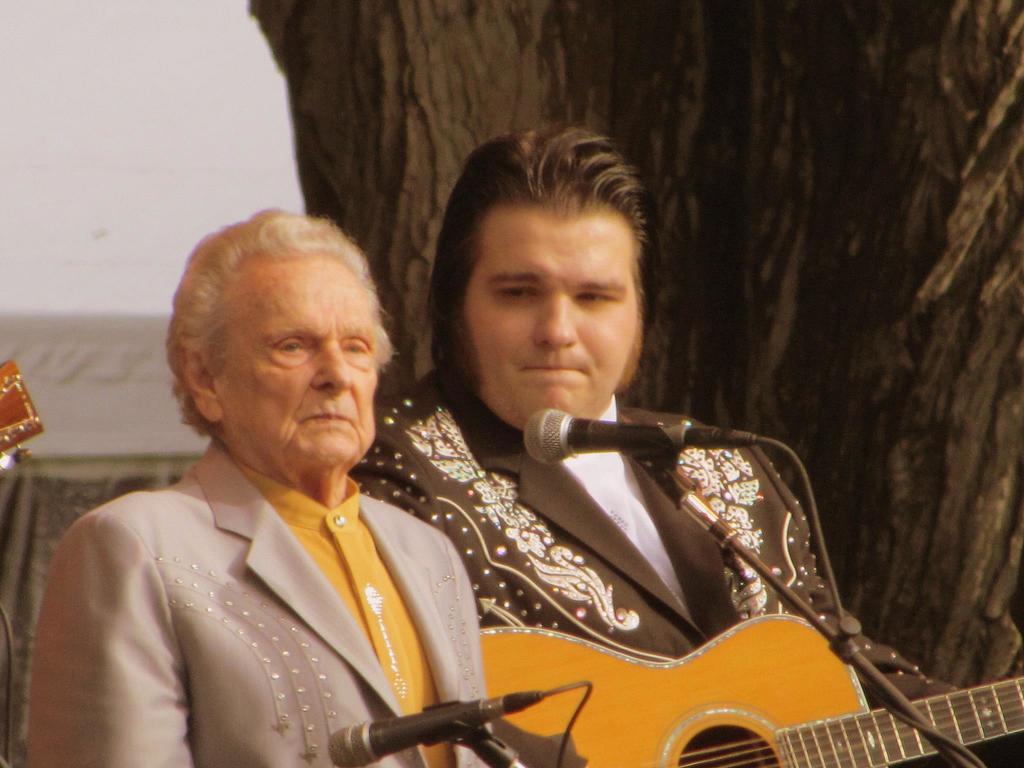In one or two sentences, can you explain what this image depicts? In this picture there are two persons standing on a stage. The man in black coat was holding a guitar. In front of these people there are microphone with stand. Behind the people there is a tree and a wall. 